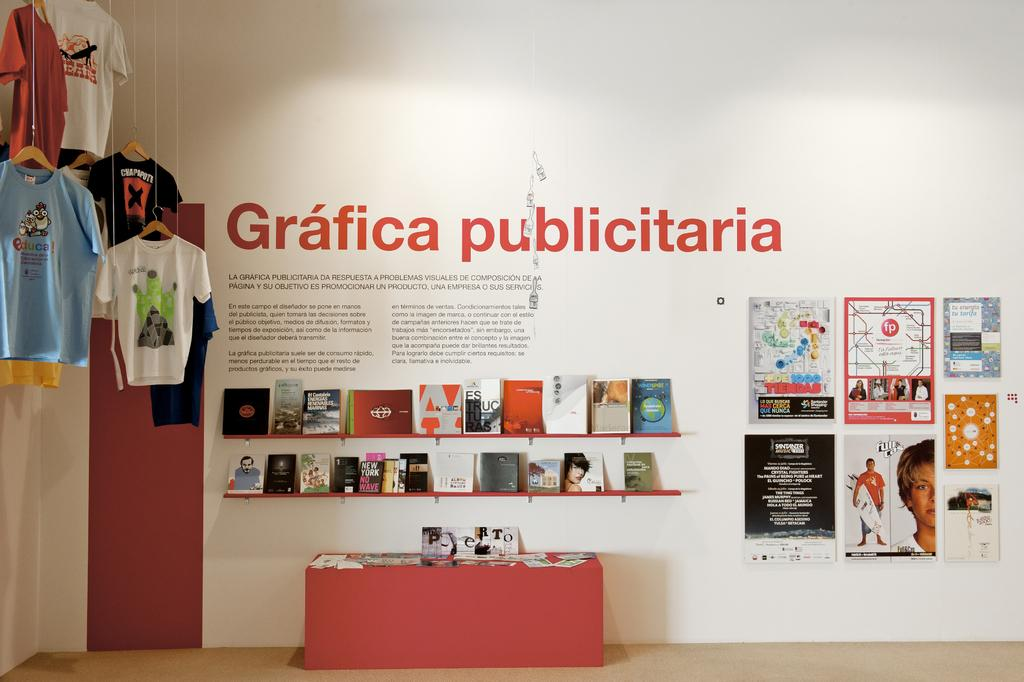<image>
Relay a brief, clear account of the picture shown. A display of books sits in front oa mural titled Gafici publicitaria. 